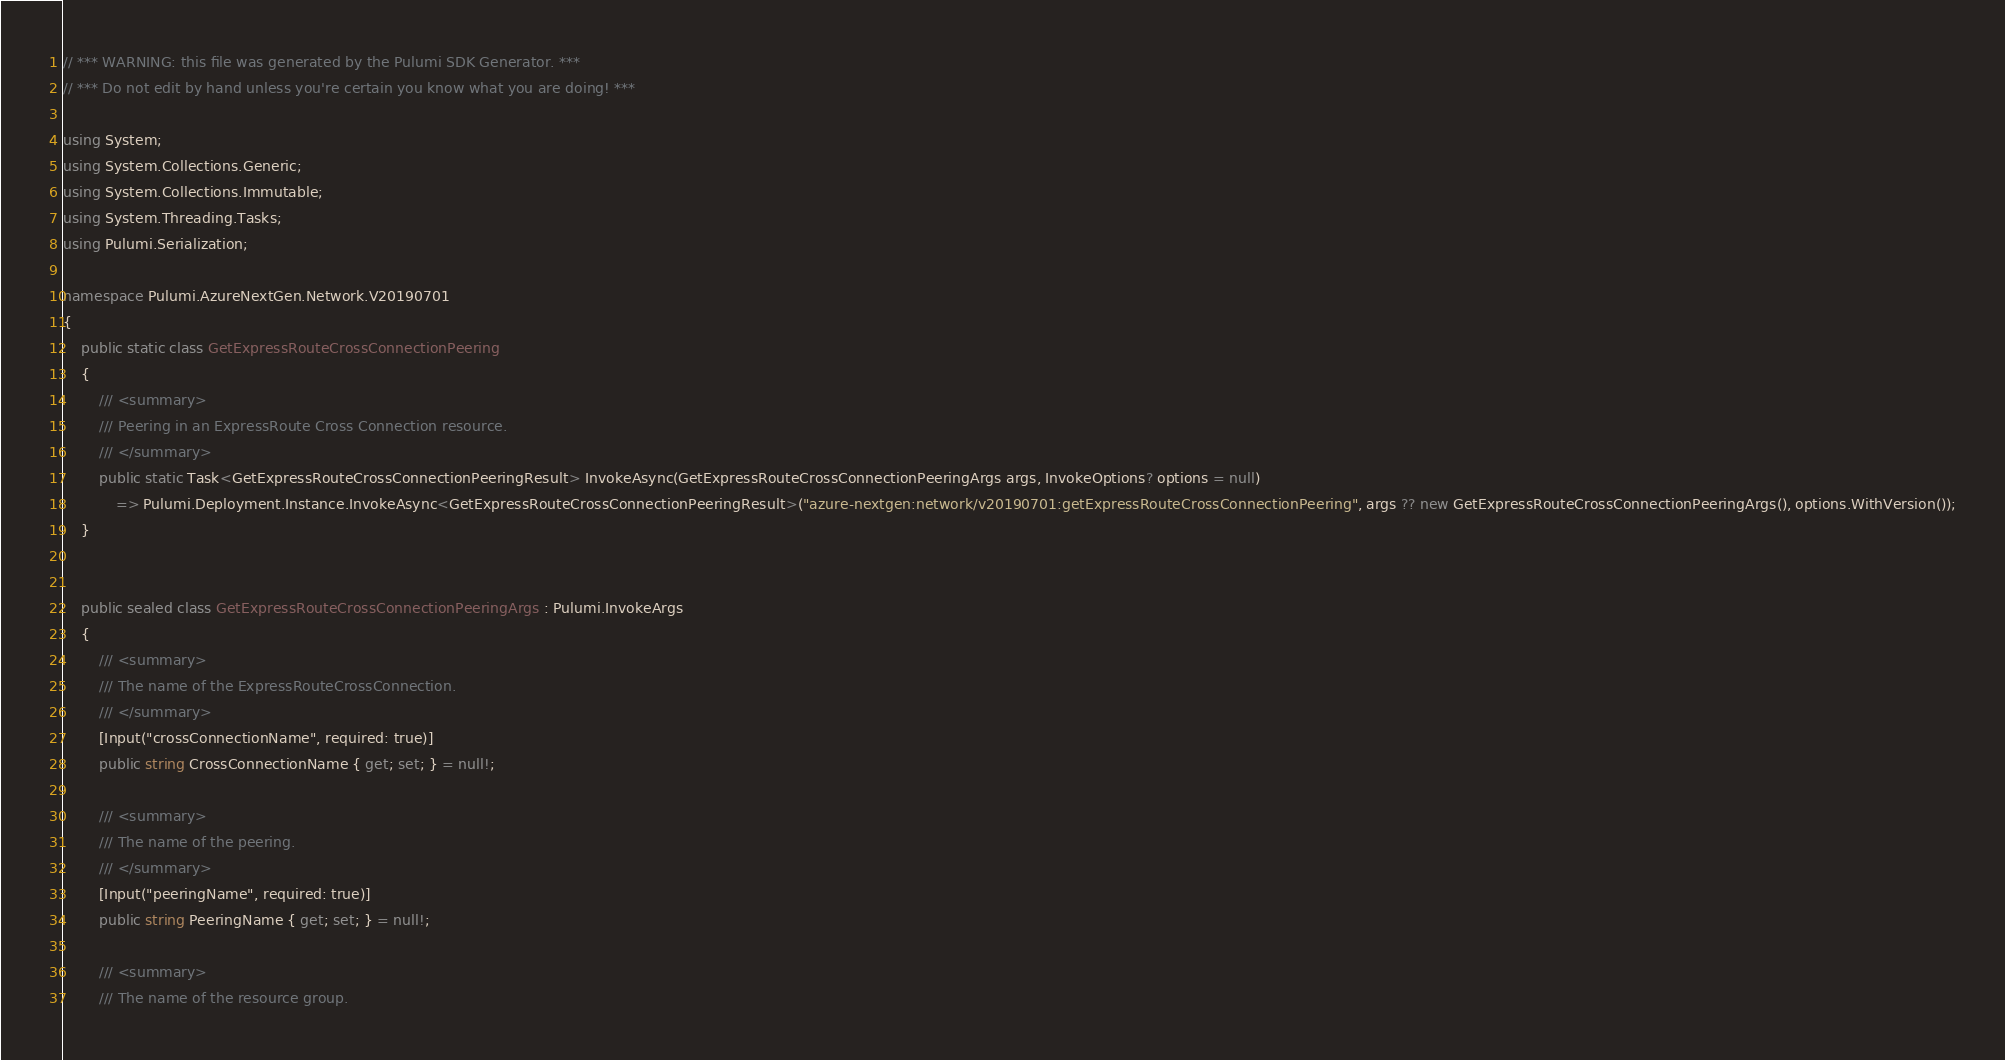Convert code to text. <code><loc_0><loc_0><loc_500><loc_500><_C#_>// *** WARNING: this file was generated by the Pulumi SDK Generator. ***
// *** Do not edit by hand unless you're certain you know what you are doing! ***

using System;
using System.Collections.Generic;
using System.Collections.Immutable;
using System.Threading.Tasks;
using Pulumi.Serialization;

namespace Pulumi.AzureNextGen.Network.V20190701
{
    public static class GetExpressRouteCrossConnectionPeering
    {
        /// <summary>
        /// Peering in an ExpressRoute Cross Connection resource.
        /// </summary>
        public static Task<GetExpressRouteCrossConnectionPeeringResult> InvokeAsync(GetExpressRouteCrossConnectionPeeringArgs args, InvokeOptions? options = null)
            => Pulumi.Deployment.Instance.InvokeAsync<GetExpressRouteCrossConnectionPeeringResult>("azure-nextgen:network/v20190701:getExpressRouteCrossConnectionPeering", args ?? new GetExpressRouteCrossConnectionPeeringArgs(), options.WithVersion());
    }


    public sealed class GetExpressRouteCrossConnectionPeeringArgs : Pulumi.InvokeArgs
    {
        /// <summary>
        /// The name of the ExpressRouteCrossConnection.
        /// </summary>
        [Input("crossConnectionName", required: true)]
        public string CrossConnectionName { get; set; } = null!;

        /// <summary>
        /// The name of the peering.
        /// </summary>
        [Input("peeringName", required: true)]
        public string PeeringName { get; set; } = null!;

        /// <summary>
        /// The name of the resource group.</code> 